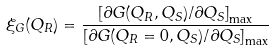Convert formula to latex. <formula><loc_0><loc_0><loc_500><loc_500>\xi _ { G } ( Q _ { R } ) = \frac { \left [ \partial G ( Q _ { R } , Q _ { S } ) / \partial Q _ { S } \right ] _ { \max } } { \left [ \partial G ( Q _ { R } = 0 , Q _ { S } ) / \partial Q _ { S } \right ] _ { \max } }</formula> 